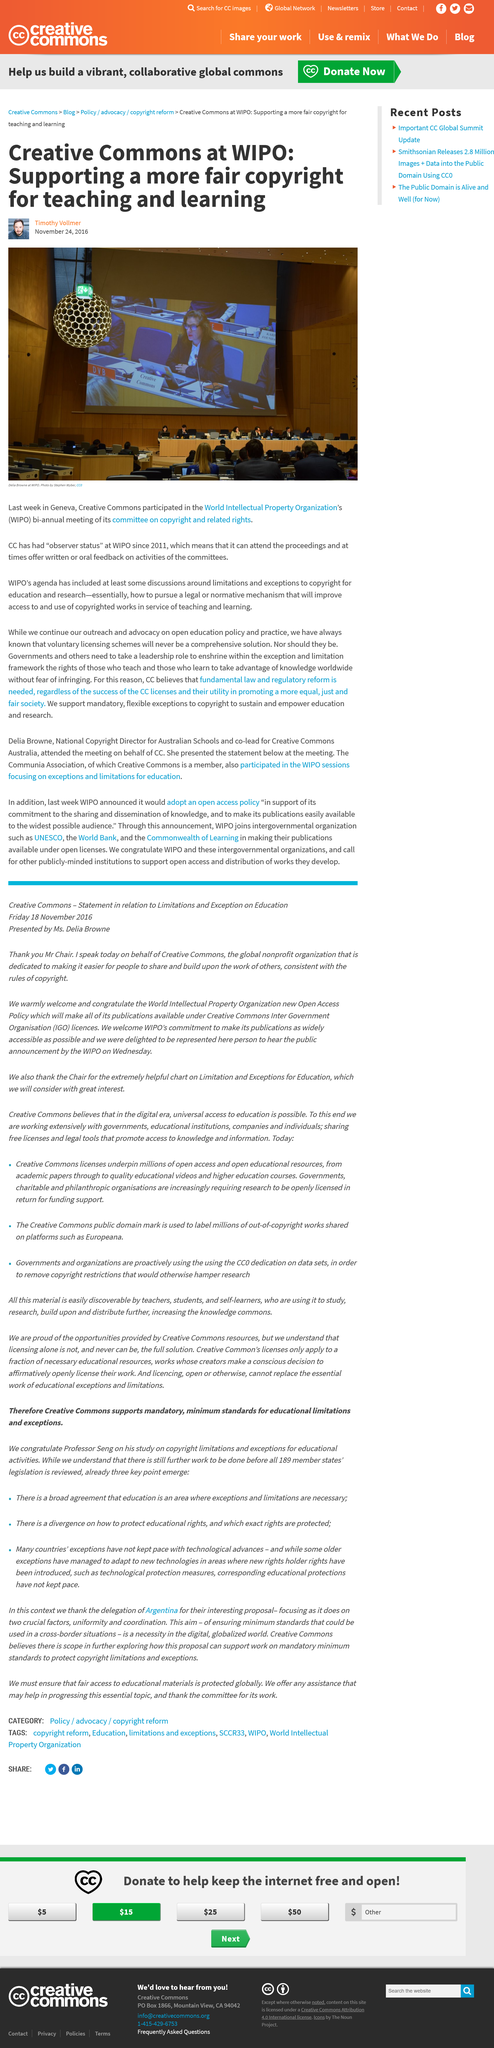Point out several critical features in this image. Observer status at the World Intellectual Property Organization (WIPO) allows an organization to attend the proceedings and provide written or oral feedback on the activities of the committees. Creative Commons has held observer status at WIPO since 2011. The World Intellectual Property Organization (WIPO) is an acronym that stands for a global organization dedicated to promoting and protecting intellectual property rights. 